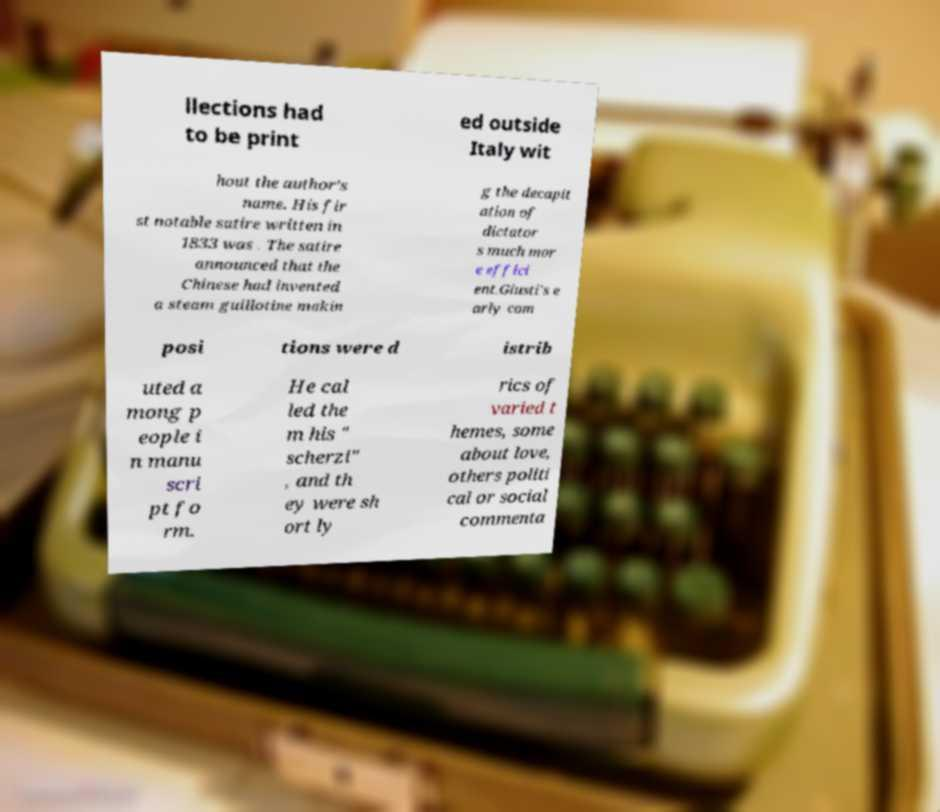Could you assist in decoding the text presented in this image and type it out clearly? llections had to be print ed outside Italy wit hout the author’s name. His fir st notable satire written in 1833 was . The satire announced that the Chinese had invented a steam guillotine makin g the decapit ation of dictator s much mor e effici ent.Giusti's e arly com posi tions were d istrib uted a mong p eople i n manu scri pt fo rm. He cal led the m his " scherzi" , and th ey were sh ort ly rics of varied t hemes, some about love, others politi cal or social commenta 